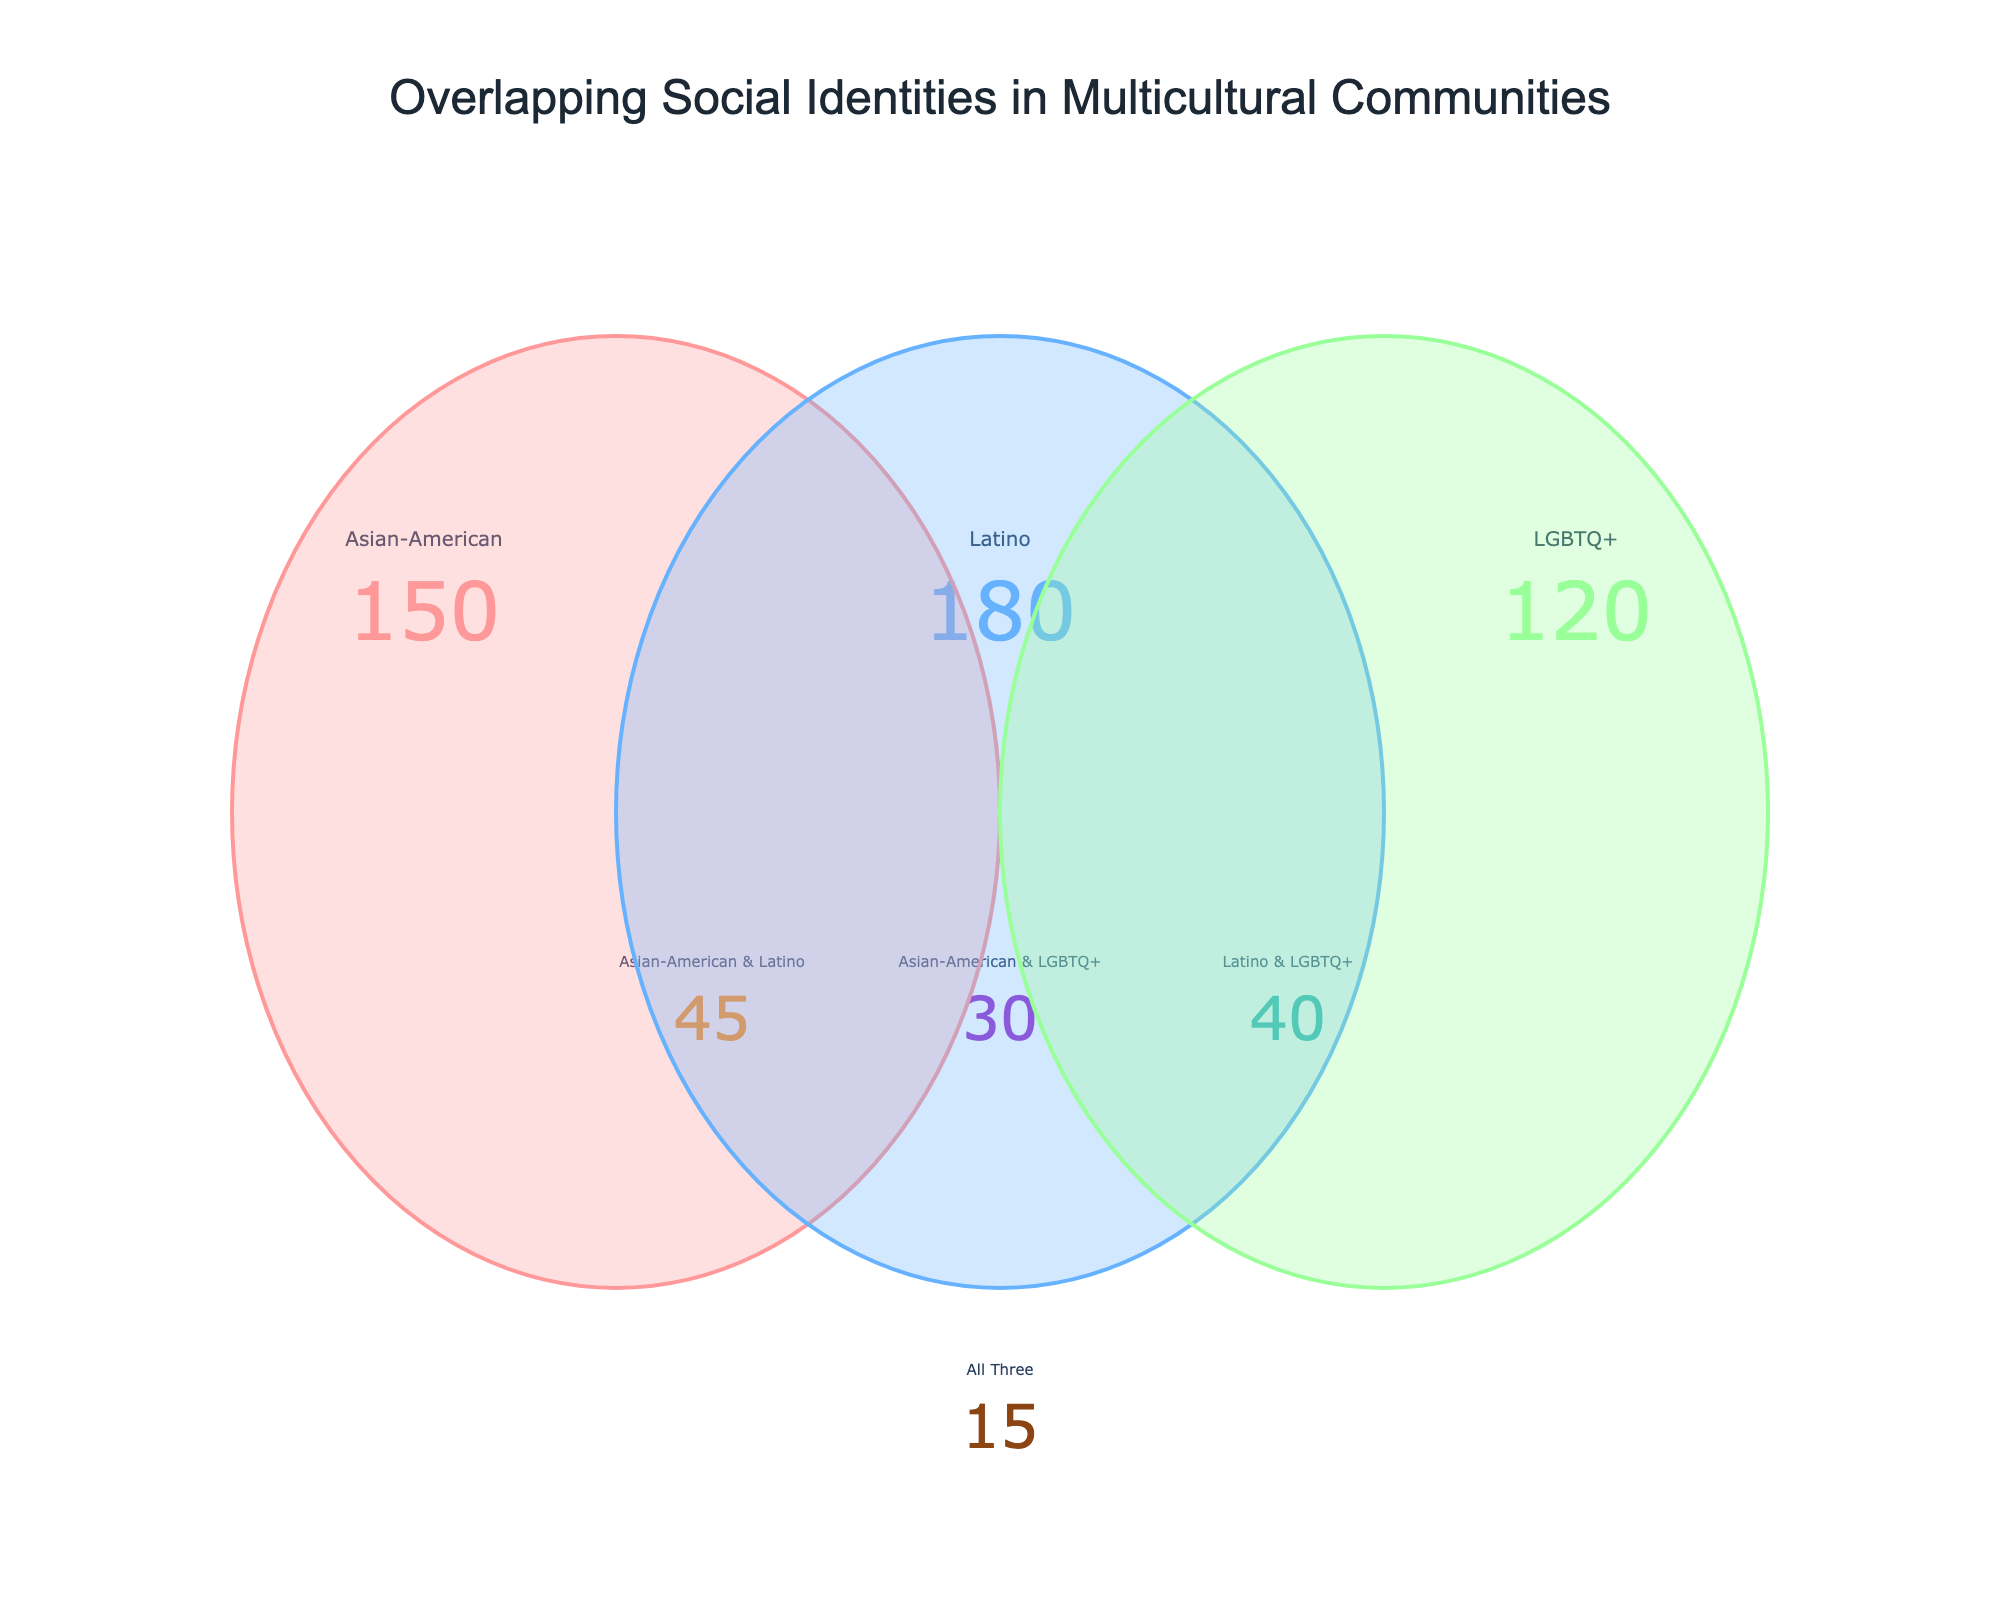What is the total number of Latino individuals? From the figure, the number associated with Latino individuals is 180.
Answer: 180 How many people identify as both Asian-American and Latino? The figure shows a value of 45 for individuals identifying as both Asian-American and Latino.
Answer: 45 Which identity has the smallest count? The figure shows 30 for Asian-American & LGBTQ+, 40 for Latino & LGBTQ+, and 15 for all three. The smallest is 15.
Answer: All three What is the total number of individuals in the figure? Add all the counts: 150 (Asian-American) + 180 (Latino) + 120 (LGBTQ+) - (45+30+40) (subtracted for double-counting overlaps) + 15 (added back as it was subtracted three times): 150 + 180 + 120 - 115 + 15 = 350.
Answer: 350 How many more Latino individuals are there compared to Asian-American individuals? There are 180 Latinos and 150 Asian-Americans. The difference is calculated as 180 - 150 = 30.
Answer: 30 Which intersection group has the highest number of people? Among the intersection groups, Latino & LGBTQ+ has the highest count with a value of 40.
Answer: Latino & LGBTQ+ How many people identify as Latino but not as Asian-American or LGBTQ+? Subtract overlaps where Latino is combined with other identities: 180 (Latino) - 45 (Asian-American & Latino) - 40 (Latino & LGBTQ+) + 15 (all three to not double count): 180 - 45 - 40 + 15 = 110.
Answer: 110 What is the proportion of LGBTQ+ individuals within the Latino & LGBTQ+ group? The figure shows 40 individuals in Latino & LGBTQ+. To find the proportion: 40 (Latino & LGBTQ+) / 120 (LGBTQ+ total) = 1/3 or approximately 33%.
Answer: 33% What percentage of total individuals are Asian-American & Latino & LGBTQ+? There are 15 individuals in this triple intersection. The total number of individuals is 350. To find the percentage: (15 / 350) * 100 ≈ 4.29%.
Answer: 4.29% 